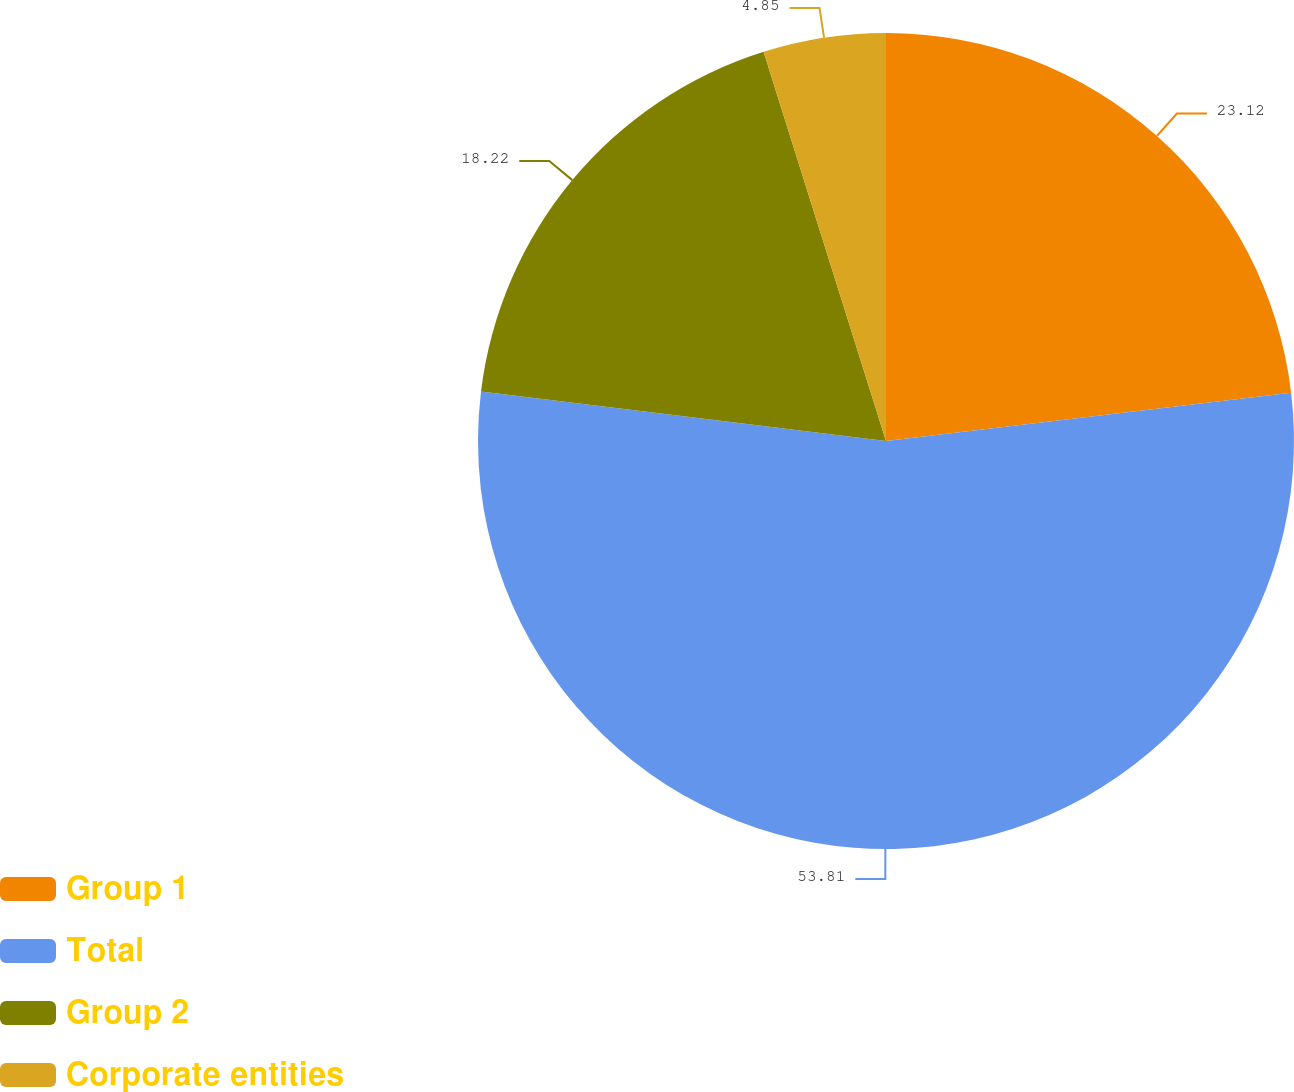Convert chart. <chart><loc_0><loc_0><loc_500><loc_500><pie_chart><fcel>Group 1<fcel>Total<fcel>Group 2<fcel>Corporate entities<nl><fcel>23.12%<fcel>53.82%<fcel>18.22%<fcel>4.85%<nl></chart> 